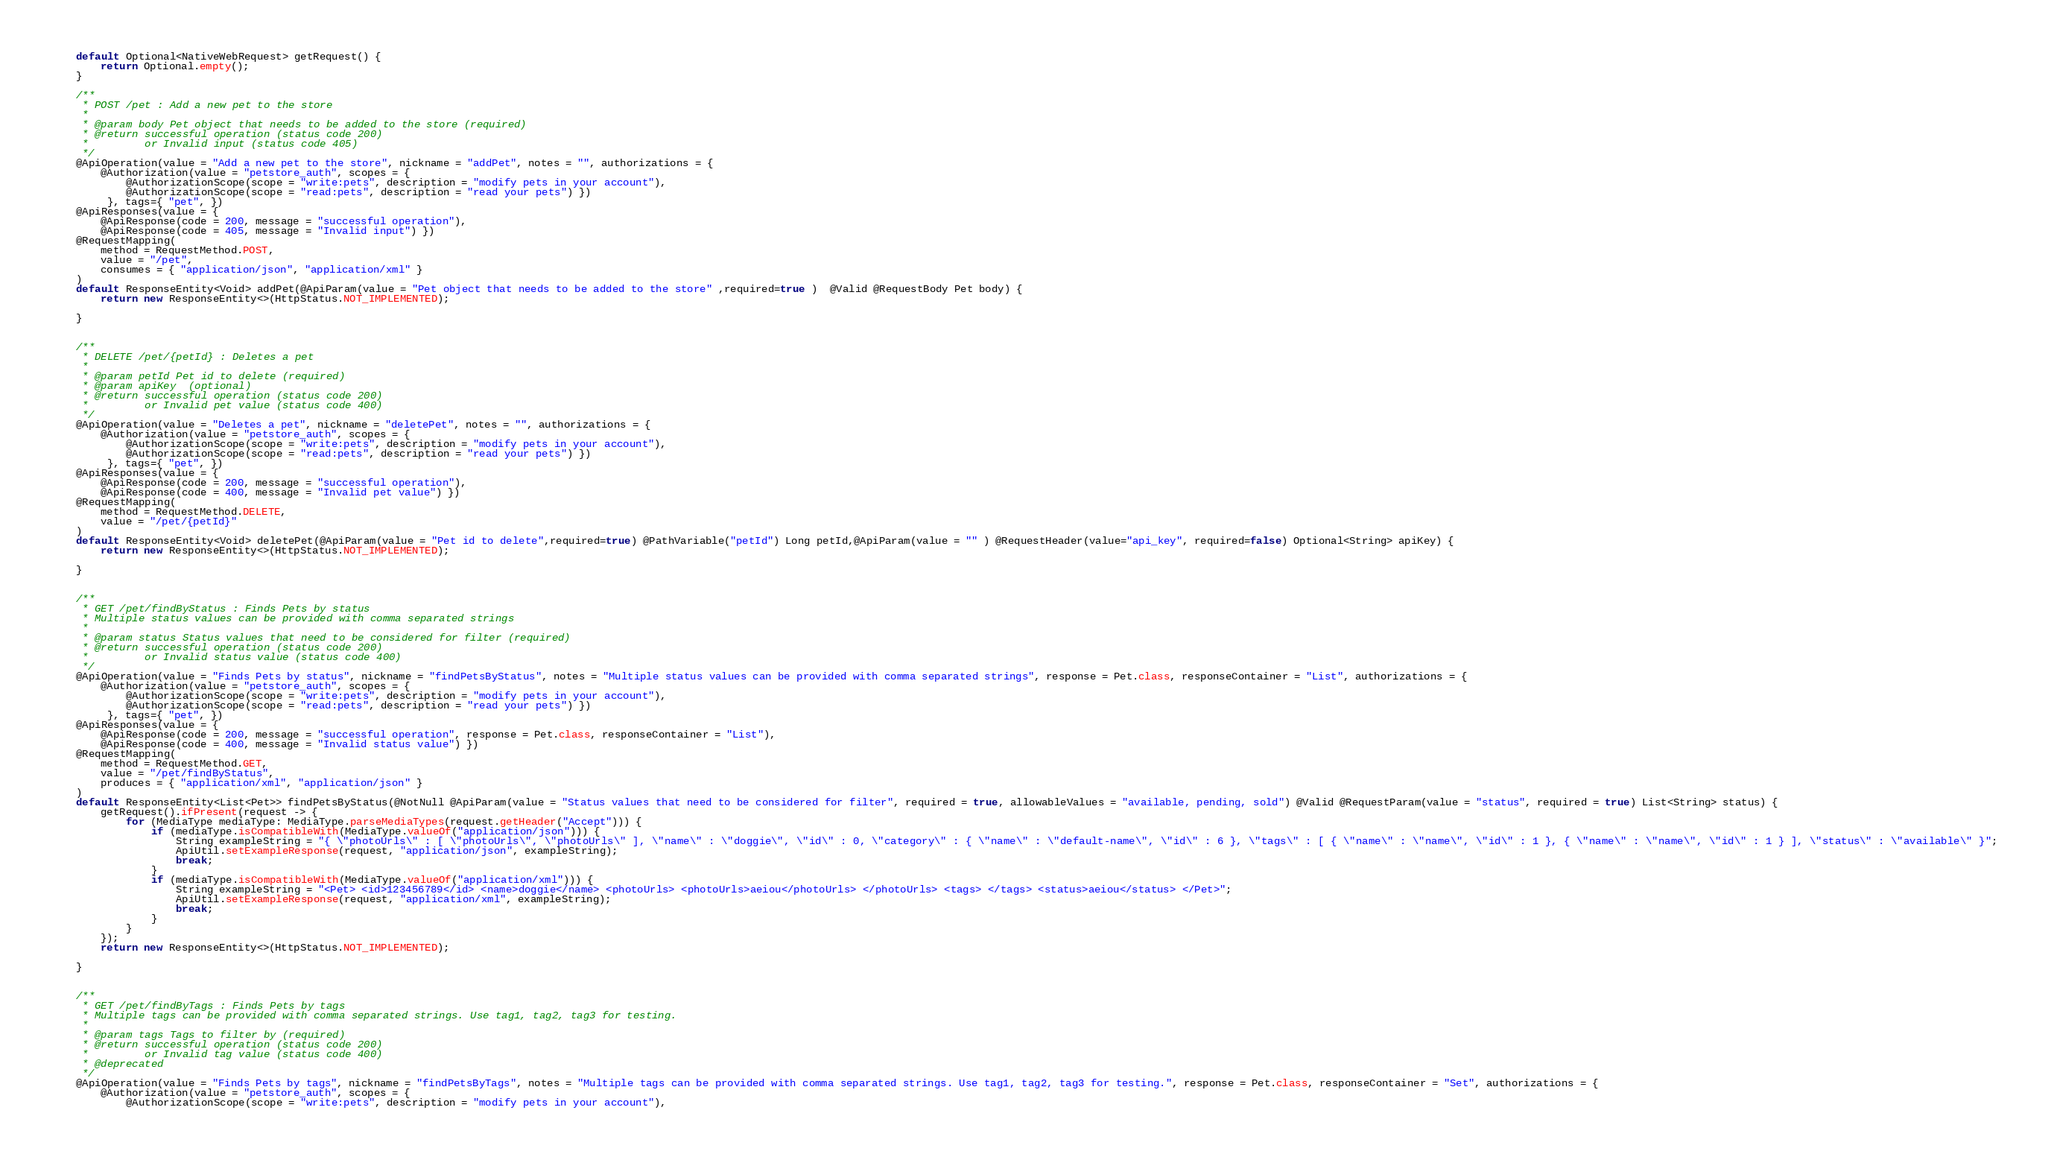Convert code to text. <code><loc_0><loc_0><loc_500><loc_500><_Java_>    default Optional<NativeWebRequest> getRequest() {
        return Optional.empty();
    }

    /**
     * POST /pet : Add a new pet to the store
     *
     * @param body Pet object that needs to be added to the store (required)
     * @return successful operation (status code 200)
     *         or Invalid input (status code 405)
     */
    @ApiOperation(value = "Add a new pet to the store", nickname = "addPet", notes = "", authorizations = {
        @Authorization(value = "petstore_auth", scopes = {
            @AuthorizationScope(scope = "write:pets", description = "modify pets in your account"),
            @AuthorizationScope(scope = "read:pets", description = "read your pets") })
         }, tags={ "pet", })
    @ApiResponses(value = { 
        @ApiResponse(code = 200, message = "successful operation"),
        @ApiResponse(code = 405, message = "Invalid input") })
    @RequestMapping(
        method = RequestMethod.POST,
        value = "/pet",
        consumes = { "application/json", "application/xml" }
    )
    default ResponseEntity<Void> addPet(@ApiParam(value = "Pet object that needs to be added to the store" ,required=true )  @Valid @RequestBody Pet body) {
        return new ResponseEntity<>(HttpStatus.NOT_IMPLEMENTED);

    }


    /**
     * DELETE /pet/{petId} : Deletes a pet
     *
     * @param petId Pet id to delete (required)
     * @param apiKey  (optional)
     * @return successful operation (status code 200)
     *         or Invalid pet value (status code 400)
     */
    @ApiOperation(value = "Deletes a pet", nickname = "deletePet", notes = "", authorizations = {
        @Authorization(value = "petstore_auth", scopes = {
            @AuthorizationScope(scope = "write:pets", description = "modify pets in your account"),
            @AuthorizationScope(scope = "read:pets", description = "read your pets") })
         }, tags={ "pet", })
    @ApiResponses(value = { 
        @ApiResponse(code = 200, message = "successful operation"),
        @ApiResponse(code = 400, message = "Invalid pet value") })
    @RequestMapping(
        method = RequestMethod.DELETE,
        value = "/pet/{petId}"
    )
    default ResponseEntity<Void> deletePet(@ApiParam(value = "Pet id to delete",required=true) @PathVariable("petId") Long petId,@ApiParam(value = "" ) @RequestHeader(value="api_key", required=false) Optional<String> apiKey) {
        return new ResponseEntity<>(HttpStatus.NOT_IMPLEMENTED);

    }


    /**
     * GET /pet/findByStatus : Finds Pets by status
     * Multiple status values can be provided with comma separated strings
     *
     * @param status Status values that need to be considered for filter (required)
     * @return successful operation (status code 200)
     *         or Invalid status value (status code 400)
     */
    @ApiOperation(value = "Finds Pets by status", nickname = "findPetsByStatus", notes = "Multiple status values can be provided with comma separated strings", response = Pet.class, responseContainer = "List", authorizations = {
        @Authorization(value = "petstore_auth", scopes = {
            @AuthorizationScope(scope = "write:pets", description = "modify pets in your account"),
            @AuthorizationScope(scope = "read:pets", description = "read your pets") })
         }, tags={ "pet", })
    @ApiResponses(value = { 
        @ApiResponse(code = 200, message = "successful operation", response = Pet.class, responseContainer = "List"),
        @ApiResponse(code = 400, message = "Invalid status value") })
    @RequestMapping(
        method = RequestMethod.GET,
        value = "/pet/findByStatus",
        produces = { "application/xml", "application/json" }
    )
    default ResponseEntity<List<Pet>> findPetsByStatus(@NotNull @ApiParam(value = "Status values that need to be considered for filter", required = true, allowableValues = "available, pending, sold") @Valid @RequestParam(value = "status", required = true) List<String> status) {
        getRequest().ifPresent(request -> {
            for (MediaType mediaType: MediaType.parseMediaTypes(request.getHeader("Accept"))) {
                if (mediaType.isCompatibleWith(MediaType.valueOf("application/json"))) {
                    String exampleString = "{ \"photoUrls\" : [ \"photoUrls\", \"photoUrls\" ], \"name\" : \"doggie\", \"id\" : 0, \"category\" : { \"name\" : \"default-name\", \"id\" : 6 }, \"tags\" : [ { \"name\" : \"name\", \"id\" : 1 }, { \"name\" : \"name\", \"id\" : 1 } ], \"status\" : \"available\" }";
                    ApiUtil.setExampleResponse(request, "application/json", exampleString);
                    break;
                }
                if (mediaType.isCompatibleWith(MediaType.valueOf("application/xml"))) {
                    String exampleString = "<Pet> <id>123456789</id> <name>doggie</name> <photoUrls> <photoUrls>aeiou</photoUrls> </photoUrls> <tags> </tags> <status>aeiou</status> </Pet>";
                    ApiUtil.setExampleResponse(request, "application/xml", exampleString);
                    break;
                }
            }
        });
        return new ResponseEntity<>(HttpStatus.NOT_IMPLEMENTED);

    }


    /**
     * GET /pet/findByTags : Finds Pets by tags
     * Multiple tags can be provided with comma separated strings. Use tag1, tag2, tag3 for testing.
     *
     * @param tags Tags to filter by (required)
     * @return successful operation (status code 200)
     *         or Invalid tag value (status code 400)
     * @deprecated
     */
    @ApiOperation(value = "Finds Pets by tags", nickname = "findPetsByTags", notes = "Multiple tags can be provided with comma separated strings. Use tag1, tag2, tag3 for testing.", response = Pet.class, responseContainer = "Set", authorizations = {
        @Authorization(value = "petstore_auth", scopes = {
            @AuthorizationScope(scope = "write:pets", description = "modify pets in your account"),</code> 